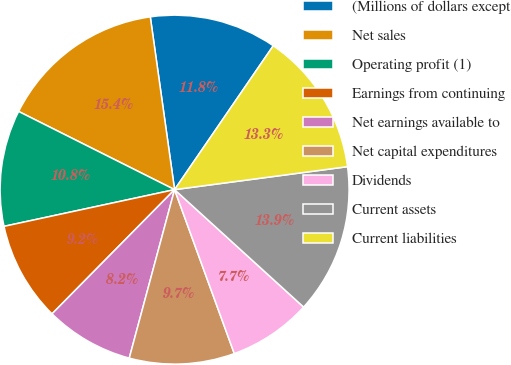<chart> <loc_0><loc_0><loc_500><loc_500><pie_chart><fcel>(Millions of dollars except<fcel>Net sales<fcel>Operating profit (1)<fcel>Earnings from continuing<fcel>Net earnings available to<fcel>Net capital expenditures<fcel>Dividends<fcel>Current assets<fcel>Current liabilities<nl><fcel>11.79%<fcel>15.38%<fcel>10.77%<fcel>9.23%<fcel>8.21%<fcel>9.74%<fcel>7.69%<fcel>13.85%<fcel>13.33%<nl></chart> 